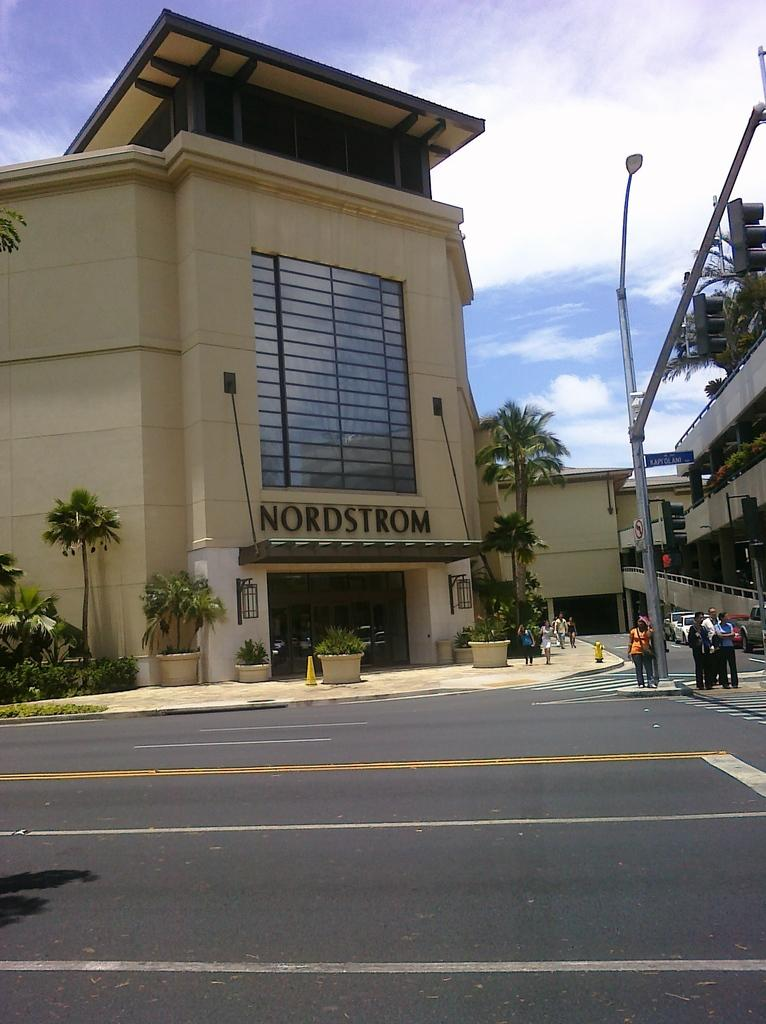<image>
Give a short and clear explanation of the subsequent image. a building with the name nordstrom over the door 